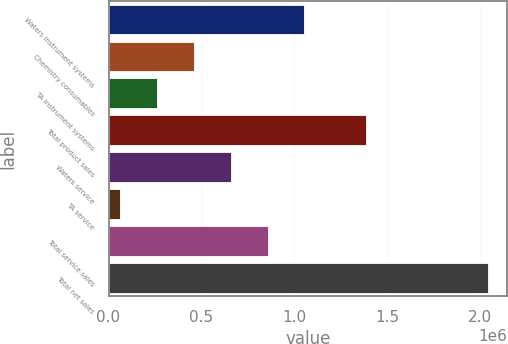Convert chart to OTSL. <chart><loc_0><loc_0><loc_500><loc_500><bar_chart><fcel>Waters instrument systems<fcel>Chemistry consumables<fcel>TA instrument systems<fcel>Total product sales<fcel>Waters service<fcel>TA service<fcel>Total service sales<fcel>Total net sales<nl><fcel>1.05305e+06<fcel>459486<fcel>261631<fcel>1.38526e+06<fcel>657342<fcel>63775<fcel>855198<fcel>2.04233e+06<nl></chart> 